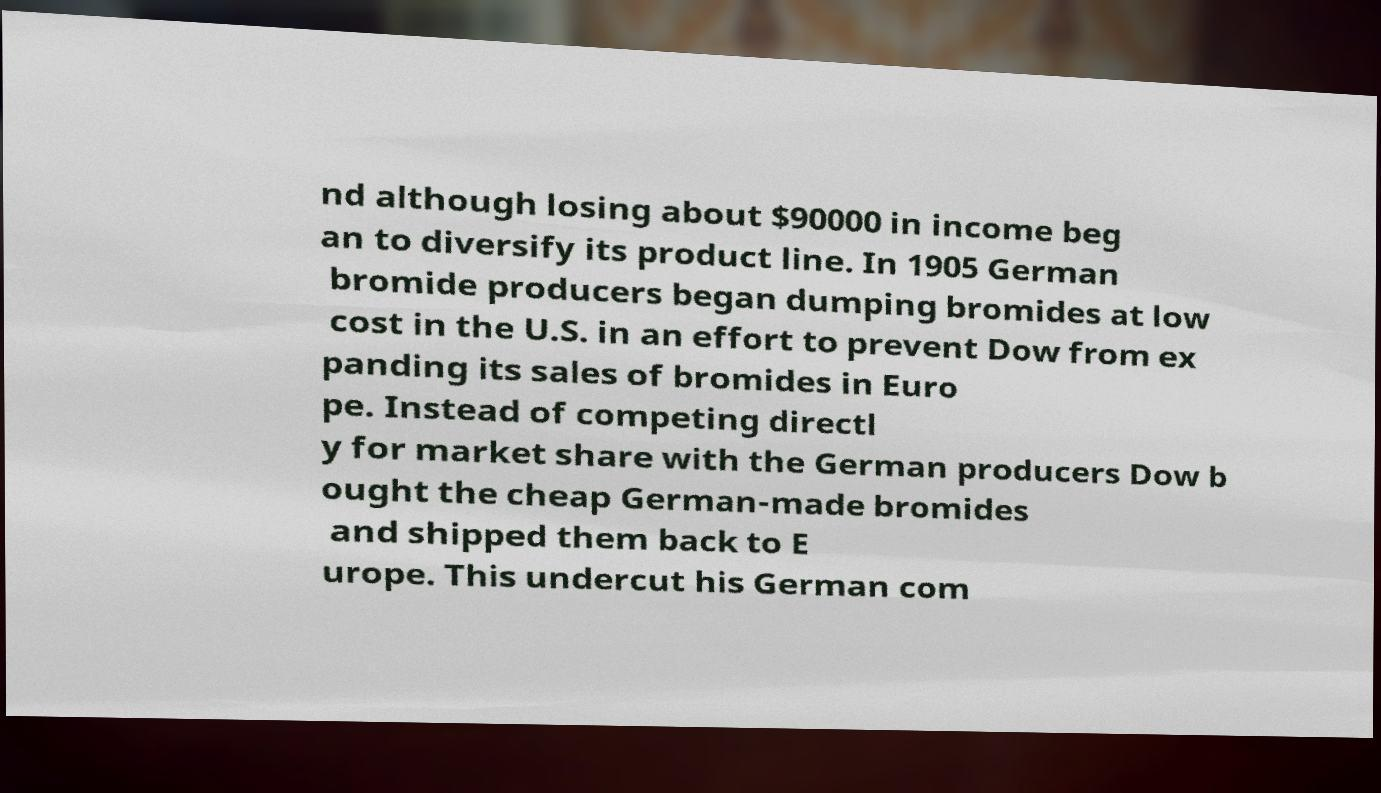Can you accurately transcribe the text from the provided image for me? nd although losing about $90000 in income beg an to diversify its product line. In 1905 German bromide producers began dumping bromides at low cost in the U.S. in an effort to prevent Dow from ex panding its sales of bromides in Euro pe. Instead of competing directl y for market share with the German producers Dow b ought the cheap German-made bromides and shipped them back to E urope. This undercut his German com 